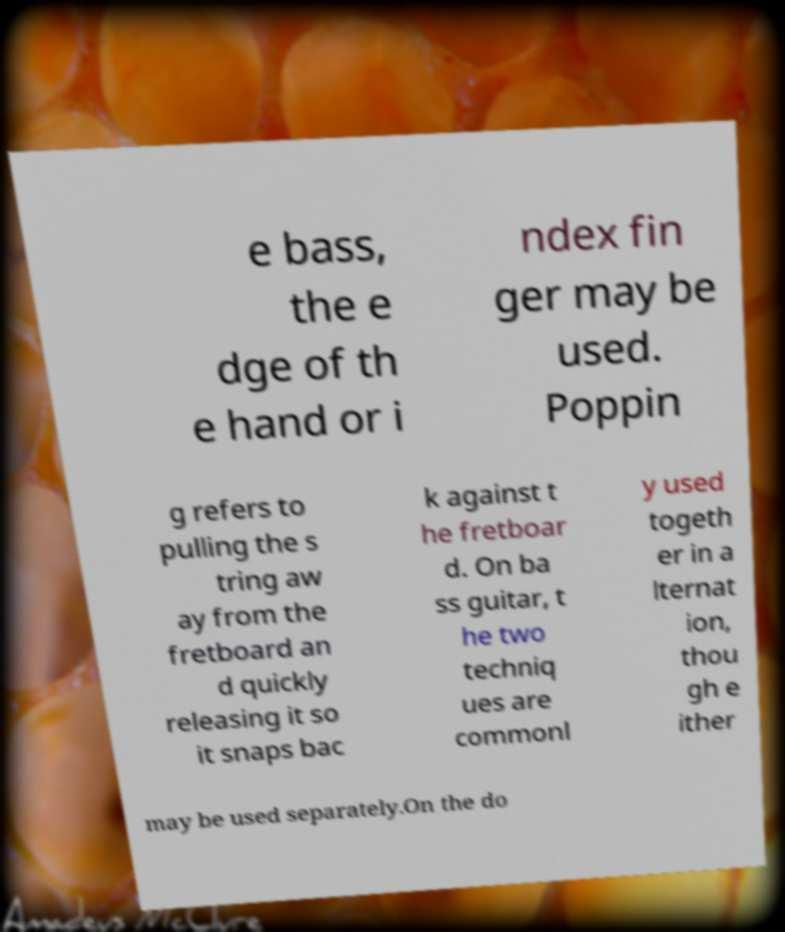What messages or text are displayed in this image? I need them in a readable, typed format. e bass, the e dge of th e hand or i ndex fin ger may be used. Poppin g refers to pulling the s tring aw ay from the fretboard an d quickly releasing it so it snaps bac k against t he fretboar d. On ba ss guitar, t he two techniq ues are commonl y used togeth er in a lternat ion, thou gh e ither may be used separately.On the do 